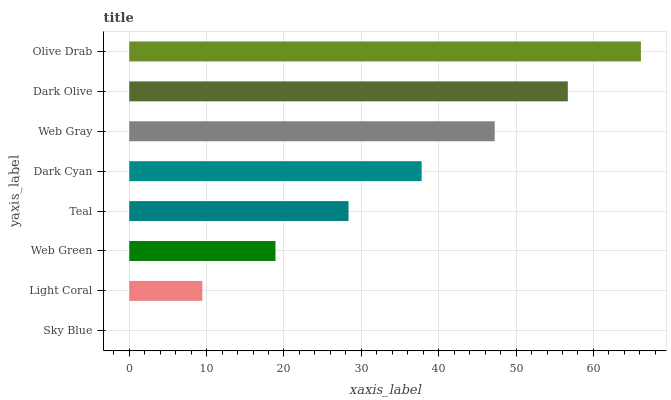Is Sky Blue the minimum?
Answer yes or no. Yes. Is Olive Drab the maximum?
Answer yes or no. Yes. Is Light Coral the minimum?
Answer yes or no. No. Is Light Coral the maximum?
Answer yes or no. No. Is Light Coral greater than Sky Blue?
Answer yes or no. Yes. Is Sky Blue less than Light Coral?
Answer yes or no. Yes. Is Sky Blue greater than Light Coral?
Answer yes or no. No. Is Light Coral less than Sky Blue?
Answer yes or no. No. Is Dark Cyan the high median?
Answer yes or no. Yes. Is Teal the low median?
Answer yes or no. Yes. Is Web Green the high median?
Answer yes or no. No. Is Dark Cyan the low median?
Answer yes or no. No. 